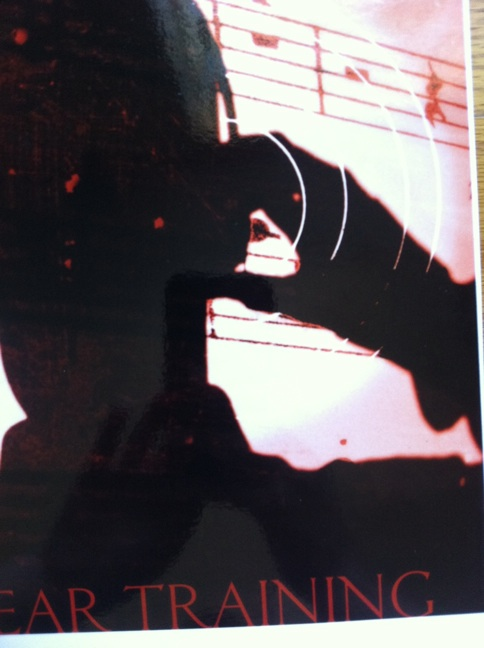Imagine this image is part of a movie scene. What could be happening in that scene? In this hypothetical movie scene, the protagonist, a dedicated musician, is deeply immersed in a late-night practice session. The dim lighting and shadowy figure convey a sense of solitude and intense focus. Sheet music surrounds the room, and the musician is practicing ear training exercises to prepare for a prestigious audition that could make or break their career. What might the background story of this character be? The character, Alex, grew up in a small town where access to music education was limited. Despite the odds, Alex's passion for music drove them to practice tirelessly on a second-hand guitar. With every note, Alex imagined themselves on grand stages, drawing emotional connections through melodies. A pivotal moment came when Alex discovered an old tape of ear training exercises, which became the cornerstone of their musical development. As Alex's talents grew, so did their dream of entering a prestigious music school to transform their passion into a lifelong career. 